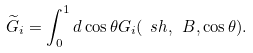<formula> <loc_0><loc_0><loc_500><loc_500>\widetilde { G } _ { i } = \int _ { 0 } ^ { 1 } d \cos \theta G _ { i } ( \ s h , \ B , \cos \theta ) .</formula> 